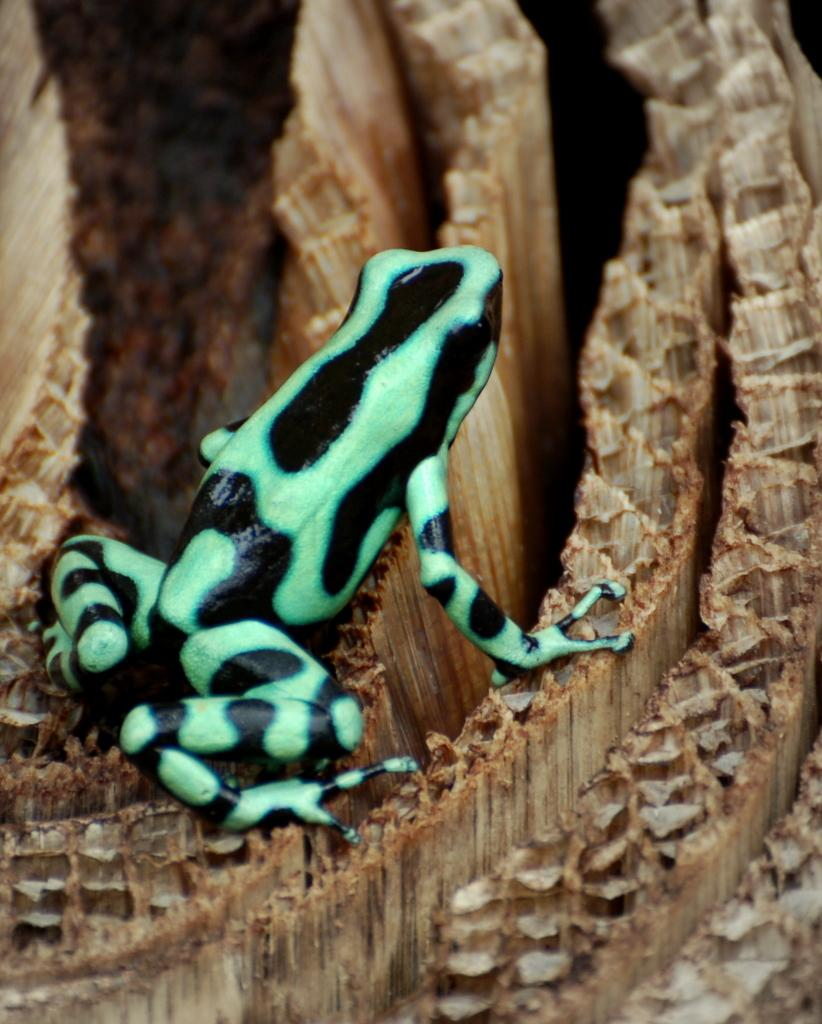What type of animal is in the image? There is a frog in the image. What is the frog sitting on? The frog is on a wooden object. What type of seed is the frog planting in the image? There is no seed present in the image, and the frog is not shown planting anything. 